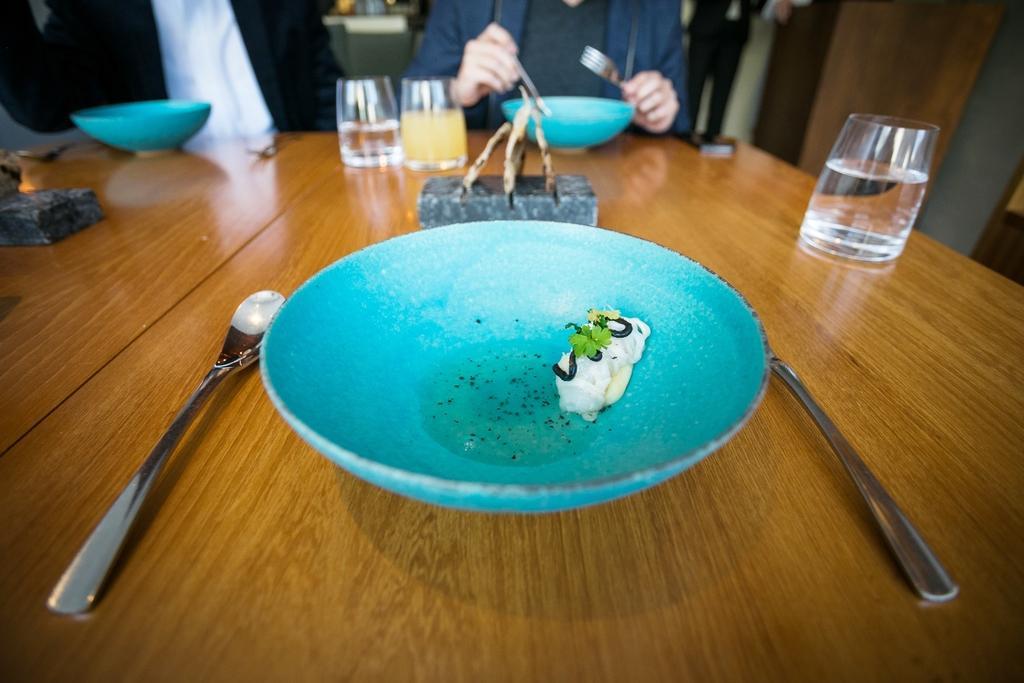Describe this image in one or two sentences. The image consists of a table on it there are plates with food, glasses,spoons. In the background two people are sitting. The person with blue jacket is holding spoon. 